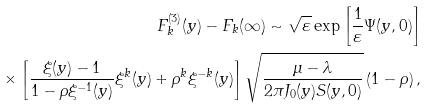<formula> <loc_0><loc_0><loc_500><loc_500>F _ { k } ^ { ( 3 ) } ( y ) - F _ { k } ( \infty ) \sim \sqrt { \varepsilon } \exp \left [ \frac { 1 } { \varepsilon } \Psi ( y , 0 ) \right ] \\ \times \left [ \frac { \xi ( y ) - 1 } { 1 - \rho \xi ^ { - 1 } ( y ) } \xi ^ { k } ( y ) + \rho ^ { k } \xi ^ { - k } ( y ) \right ] \sqrt { \frac { \mu - \lambda } { 2 \pi J _ { 0 } ( y ) S ( y , 0 ) } } \left ( 1 - \rho \right ) ,</formula> 